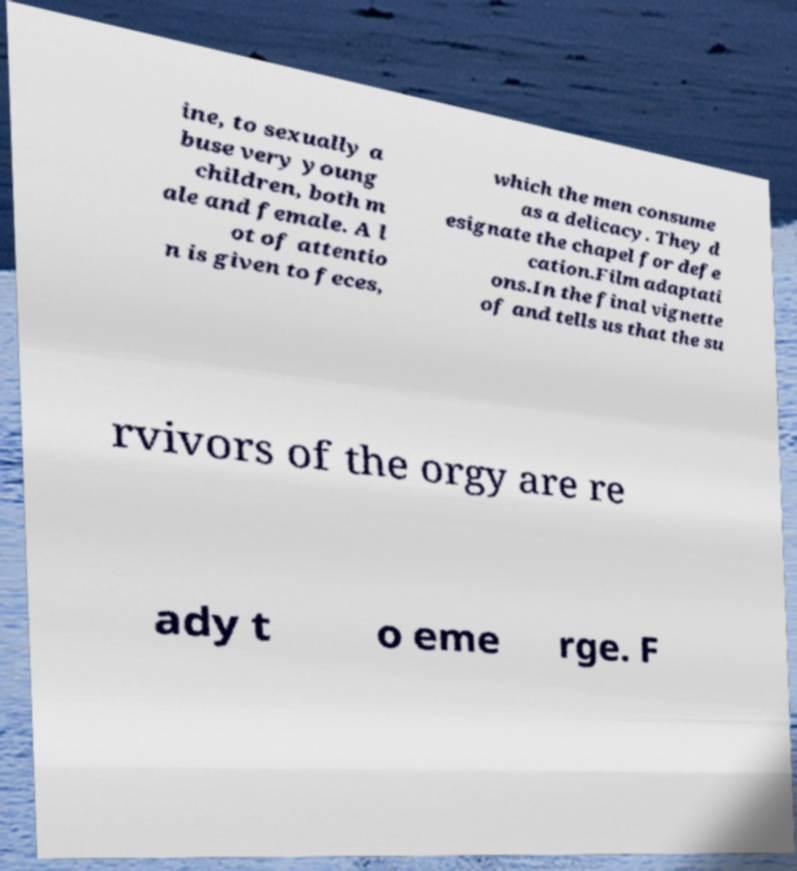Could you extract and type out the text from this image? ine, to sexually a buse very young children, both m ale and female. A l ot of attentio n is given to feces, which the men consume as a delicacy. They d esignate the chapel for defe cation.Film adaptati ons.In the final vignette of and tells us that the su rvivors of the orgy are re ady t o eme rge. F 